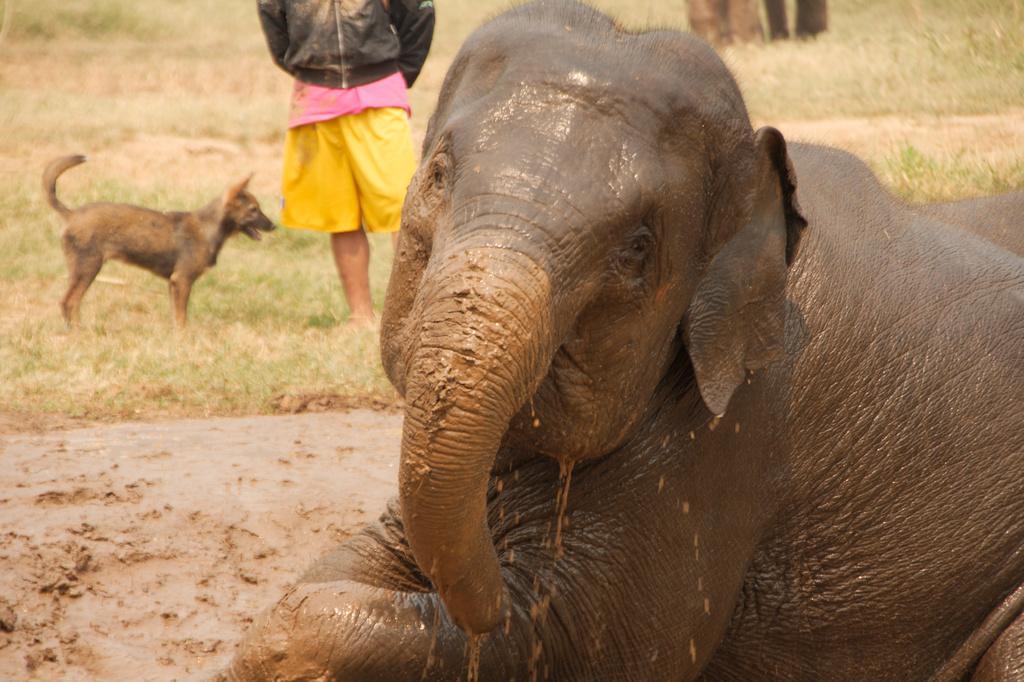In one or two sentences, can you explain what this image depicts? In this image I can see a elephant which is brown in color and I can see mud to its trunk and legs. In the background I can see the mud, a dog which is brown and black in color is standing on the ground and a person wearing black jacket and yellow short is standing on the ground. 